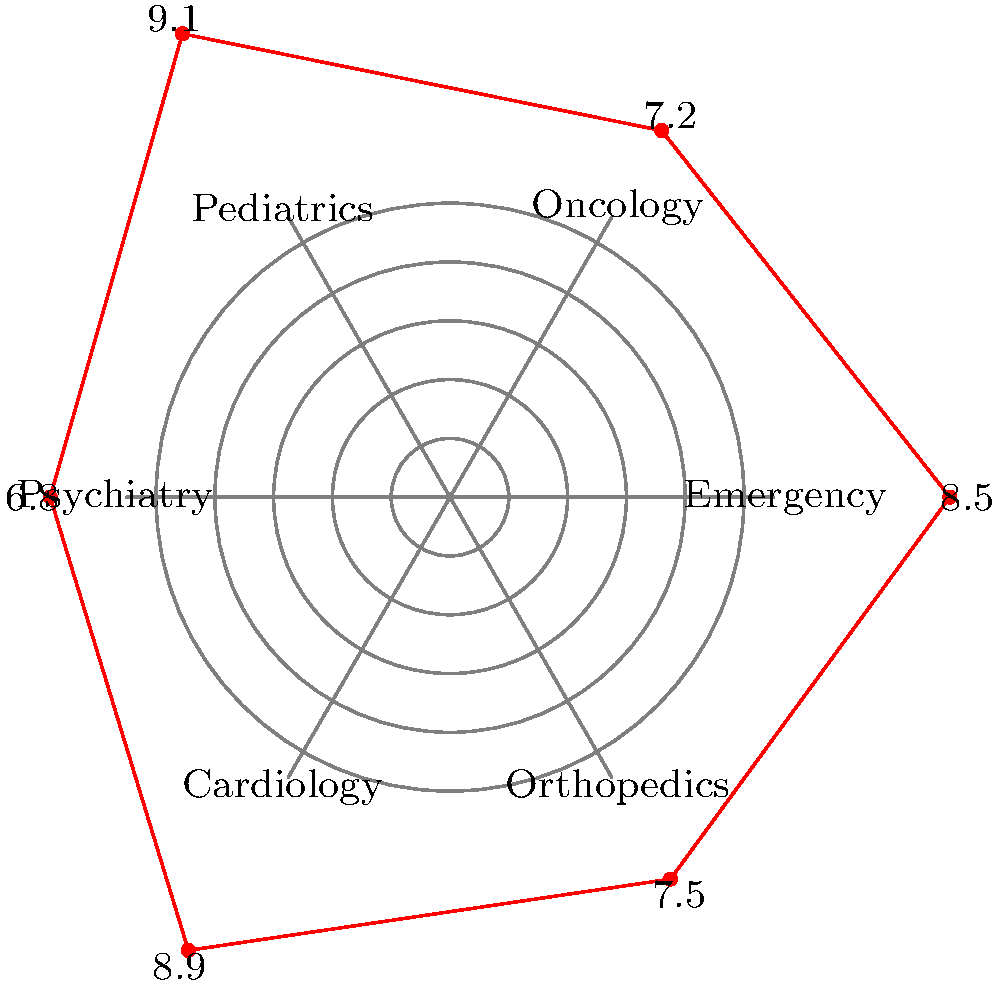Based on the radar chart of patient satisfaction scores for various hospital departments, which department has the highest satisfaction score, and how much higher is it than the department with the lowest score? To answer this question, we need to follow these steps:

1. Identify the highest satisfaction score:
   - Emergency: 8.5
   - Oncology: 7.2
   - Pediatrics: 9.1
   - Psychiatry: 6.8
   - Cardiology: 8.9
   - Orthopedics: 7.5

   The highest score is 9.1 for Pediatrics.

2. Identify the lowest satisfaction score:
   The lowest score is 6.8 for Psychiatry.

3. Calculate the difference between the highest and lowest scores:
   $9.1 - 6.8 = 2.3$

Therefore, the Pediatrics department has the highest satisfaction score, and it is 2.3 points higher than the department with the lowest score (Psychiatry).
Answer: Pediatrics; 2.3 points higher 